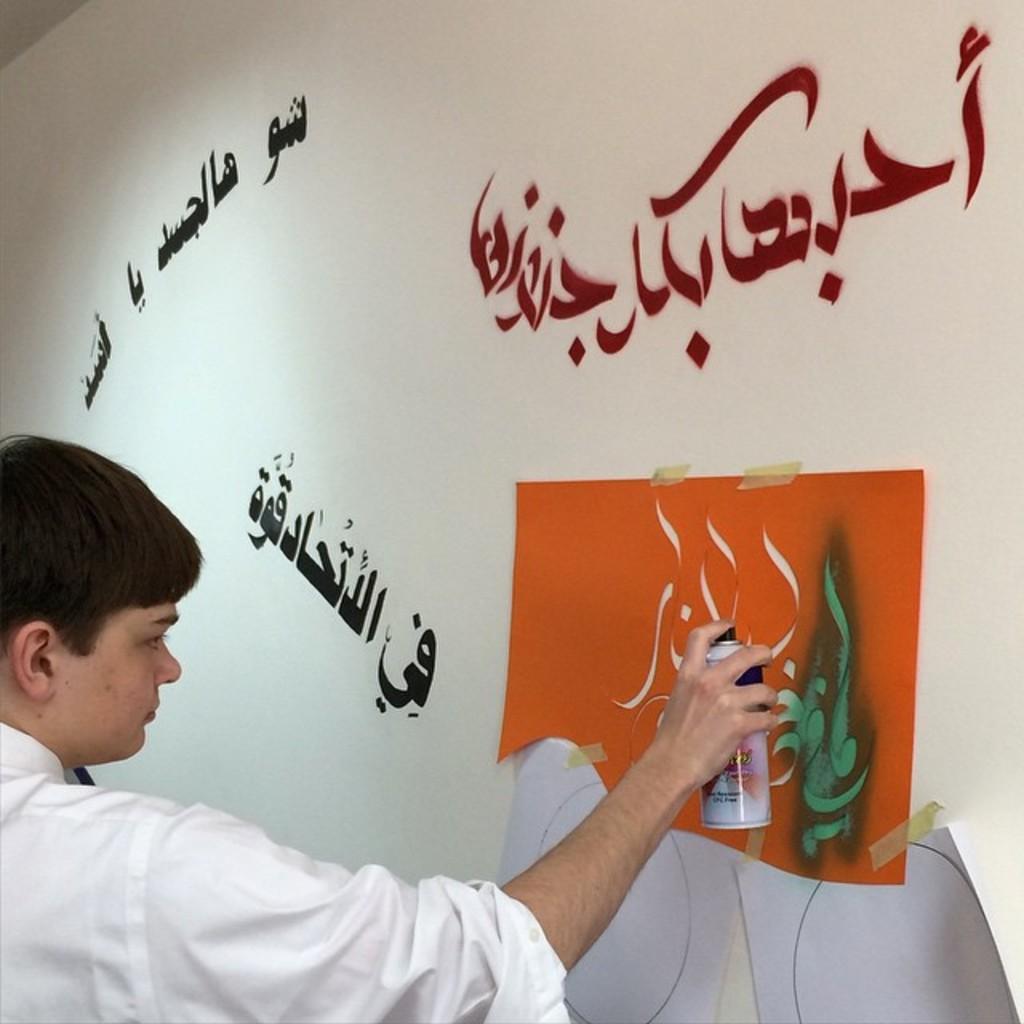In one or two sentences, can you explain what this image depicts? In this image we can see texts on the wall and there is a design cut paper attached with plasters on the wall and a man is holding color spray bottle and spraying on the paper on the wall. 